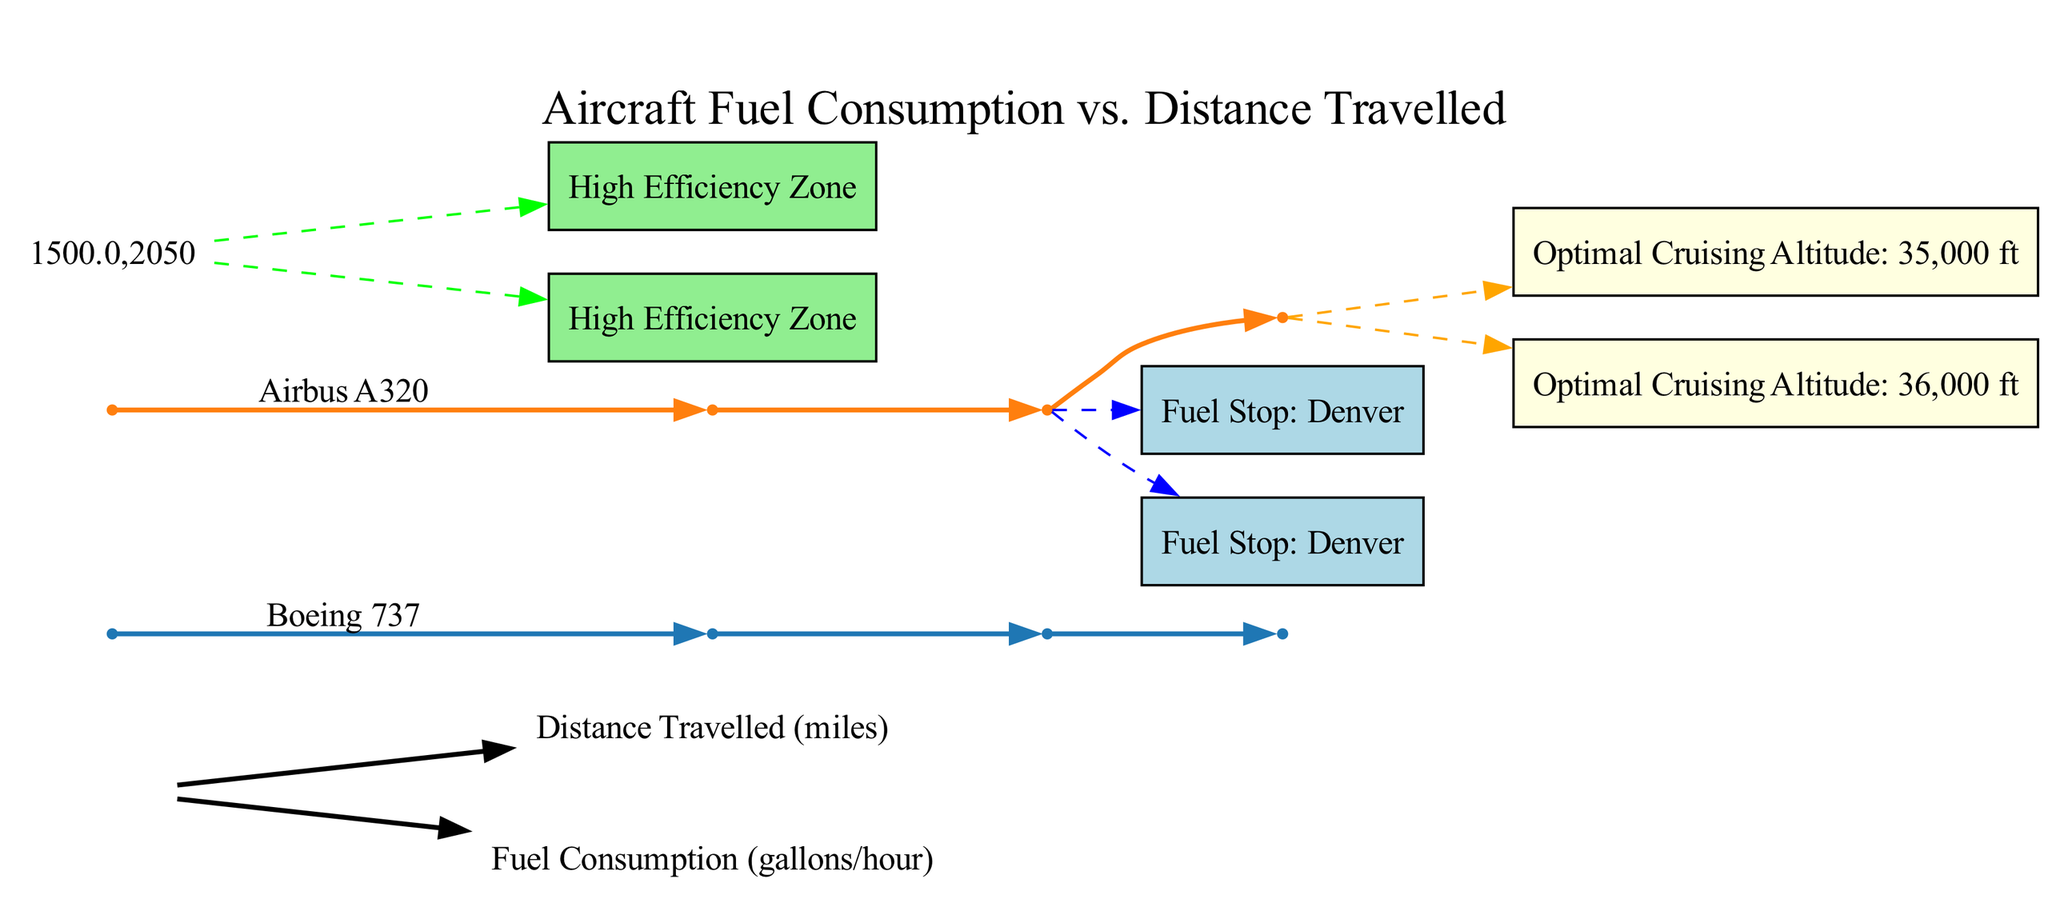What is the fuel consumption of the Boeing 737 at 1000 miles? The diagram indicates that at a distance of 1000 miles, the fuel consumption for the Boeing 737 is 1500 gallons/hour. This is directly read from the data point corresponding to the Boeing 737 curve at this distance.
Answer: 1500 gallons/hour Which aircraft model has the highest fuel consumption at 2000 miles? At 2000 miles, the Boeing 737 has a fuel consumption of 2700 gallons/hour, while the Airbus A320 consumes 2600 gallons/hour. Therefore, the Boeing 737 has the highest fuel consumption at this distance.
Answer: Boeing 737 What is the fuel stop for both aircraft models at 1500 miles? The annotations for fuel stops indicate that both the Boeing 737 and the Airbus A320 stop in Denver at 1500 miles. This is reflected in the fuel stops section of the diagram.
Answer: Denver What is the optimal cruising altitude for the Airbus A320? According to the diagram's annotation for optimal cruising altitudes, the Airbus A320 has an optimal cruising altitude of 36,000 feet. This information is specifically listed under the corresponding aircraft model.
Answer: 36,000 ft In which distance range do both aircraft models experience a high efficiency zone? The diagram shows that both aircraft models, Boeing 737 and Airbus A320, are in a high efficiency zone from 1000 to 2000 miles. This is noted in the annotations section of the diagram.
Answer: 1000 to 2000 miles What is the fuel consumption of the Airbus A320 at 500 miles? At 500 miles, the fuel consumption for the Airbus A320, as per the diagram, is 750 gallons/hour. This is taken from the data points specified for this aircraft model at this distance.
Answer: 750 gallons/hour How many data points are provided for each aircraft model in the diagram? Each aircraft model, Boeing 737 and Airbus A320, has four data points specified for distances of 500, 1000, 1500, and 2000 miles. The total count of data points for each model is four.
Answer: 4 What is the fuel consumption of the Boeing 737 in the high efficiency zone at 1500 miles? In the high efficiency zone, the fuel consumption of the Boeing 737 at 1500 miles is 2150 gallons/hour. This is inferred from the specific data point for the Boeing 737 at that distance.
Answer: 2150 gallons/hour Which aircraft model has a fuel stop indicated in the annotations? Both the Boeing 737 and the Airbus A320 have a fuel stop indicated in the annotations at 1500 miles. The fuel stop for both is Denver. Thus, both aircraft models have this in common.
Answer: Both models 